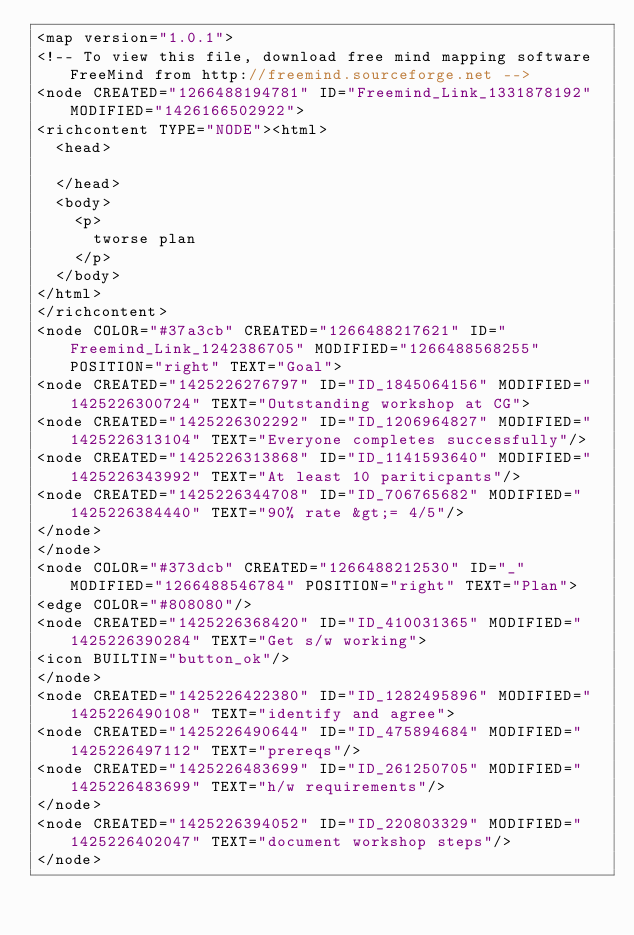Convert code to text. <code><loc_0><loc_0><loc_500><loc_500><_ObjectiveC_><map version="1.0.1">
<!-- To view this file, download free mind mapping software FreeMind from http://freemind.sourceforge.net -->
<node CREATED="1266488194781" ID="Freemind_Link_1331878192" MODIFIED="1426166502922">
<richcontent TYPE="NODE"><html>
  <head>
    
  </head>
  <body>
    <p>
      tworse plan
    </p>
  </body>
</html>
</richcontent>
<node COLOR="#37a3cb" CREATED="1266488217621" ID="Freemind_Link_1242386705" MODIFIED="1266488568255" POSITION="right" TEXT="Goal">
<node CREATED="1425226276797" ID="ID_1845064156" MODIFIED="1425226300724" TEXT="Outstanding workshop at CG">
<node CREATED="1425226302292" ID="ID_1206964827" MODIFIED="1425226313104" TEXT="Everyone completes successfully"/>
<node CREATED="1425226313868" ID="ID_1141593640" MODIFIED="1425226343992" TEXT="At least 10 pariticpants"/>
<node CREATED="1425226344708" ID="ID_706765682" MODIFIED="1425226384440" TEXT="90% rate &gt;= 4/5"/>
</node>
</node>
<node COLOR="#373dcb" CREATED="1266488212530" ID="_" MODIFIED="1266488546784" POSITION="right" TEXT="Plan">
<edge COLOR="#808080"/>
<node CREATED="1425226368420" ID="ID_410031365" MODIFIED="1425226390284" TEXT="Get s/w working">
<icon BUILTIN="button_ok"/>
</node>
<node CREATED="1425226422380" ID="ID_1282495896" MODIFIED="1425226490108" TEXT="identify and agree">
<node CREATED="1425226490644" ID="ID_475894684" MODIFIED="1425226497112" TEXT="prereqs"/>
<node CREATED="1425226483699" ID="ID_261250705" MODIFIED="1425226483699" TEXT="h/w requirements"/>
</node>
<node CREATED="1425226394052" ID="ID_220803329" MODIFIED="1425226402047" TEXT="document workshop steps"/>
</node></code> 